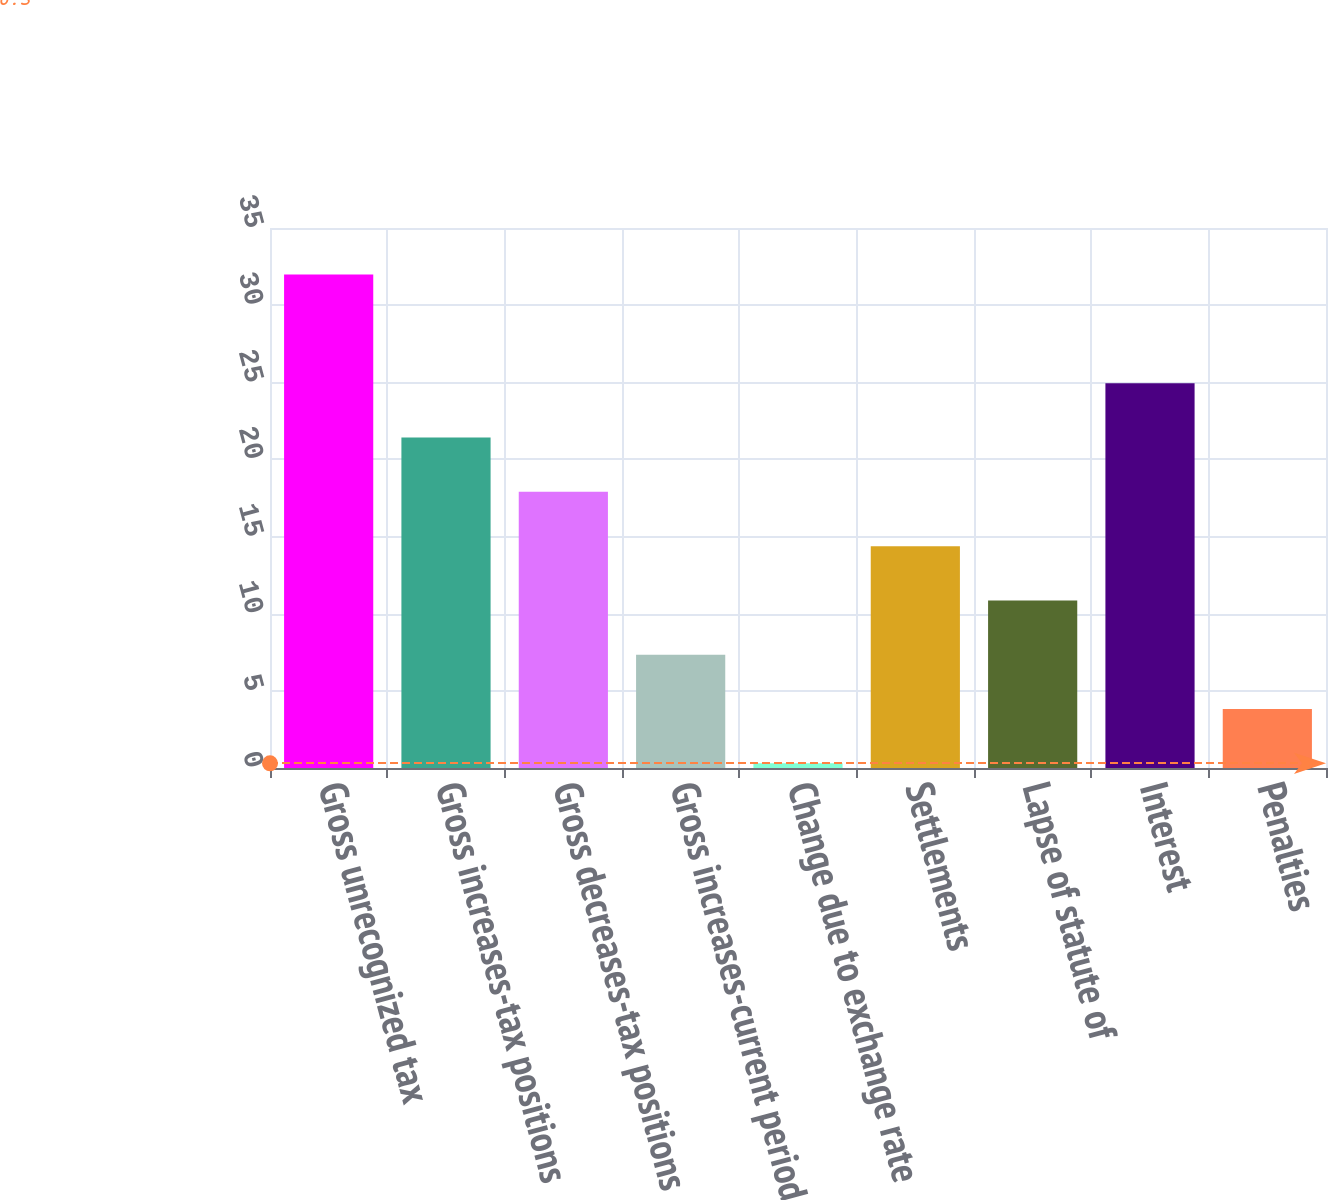Convert chart to OTSL. <chart><loc_0><loc_0><loc_500><loc_500><bar_chart><fcel>Gross unrecognized tax<fcel>Gross increases-tax positions<fcel>Gross decreases-tax positions<fcel>Gross increases-current period<fcel>Change due to exchange rate<fcel>Settlements<fcel>Lapse of statute of<fcel>Interest<fcel>Penalties<nl><fcel>31.98<fcel>21.42<fcel>17.9<fcel>7.34<fcel>0.3<fcel>14.38<fcel>10.86<fcel>24.94<fcel>3.82<nl></chart> 